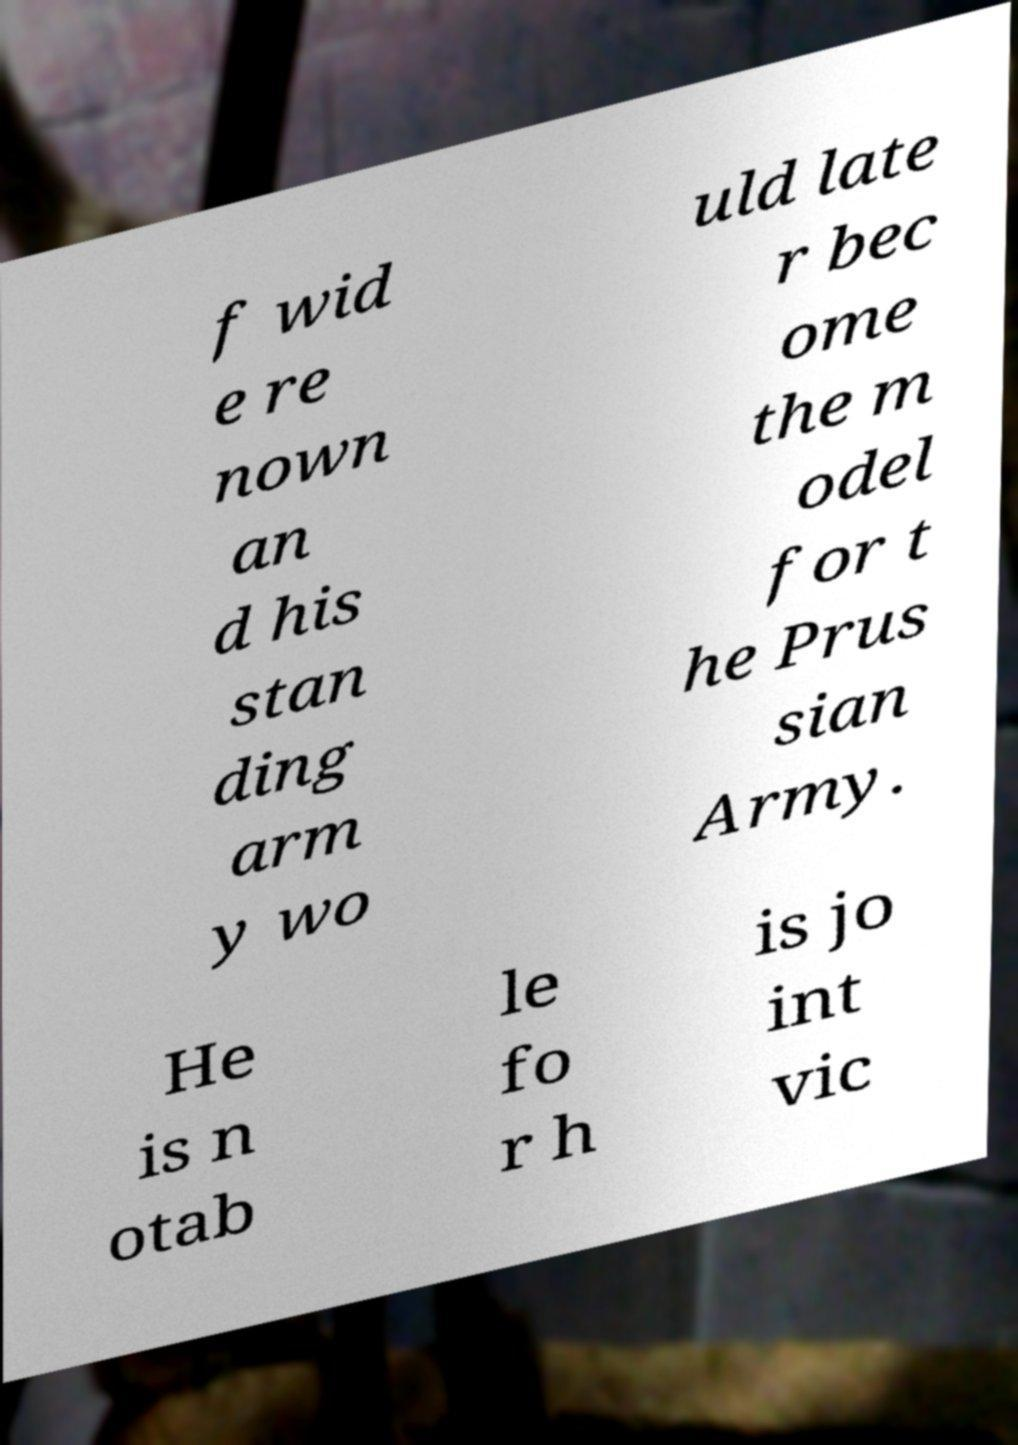Could you assist in decoding the text presented in this image and type it out clearly? f wid e re nown an d his stan ding arm y wo uld late r bec ome the m odel for t he Prus sian Army. He is n otab le fo r h is jo int vic 